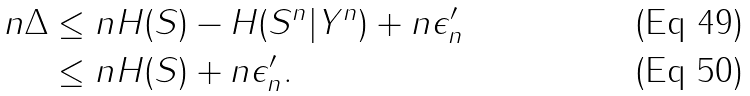Convert formula to latex. <formula><loc_0><loc_0><loc_500><loc_500>n \Delta & \leq n H ( S ) - H ( S ^ { n } | Y ^ { n } ) + n \epsilon ^ { \prime } _ { n } \\ & \leq n H ( S ) + n \epsilon ^ { \prime } _ { n } .</formula> 